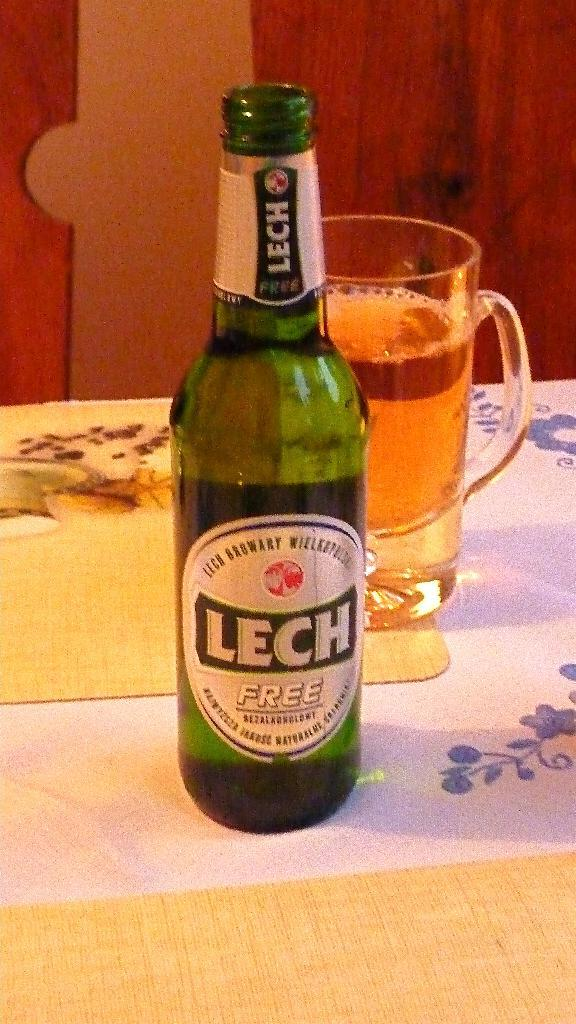What type of beverage container is present in the image? There is a beer bottle in the image. What other type of beverage container is present in the image? There is a beer glass in the image. Where are the beer bottle and beer glass located? Both the beer bottle and the beer glass are on a table. What type of food is being served with the beer in the image? There is no food present in the image; it only features a beer bottle and a beer glass. Can you tell me where the key is located in the image? There is no key present in the image. 